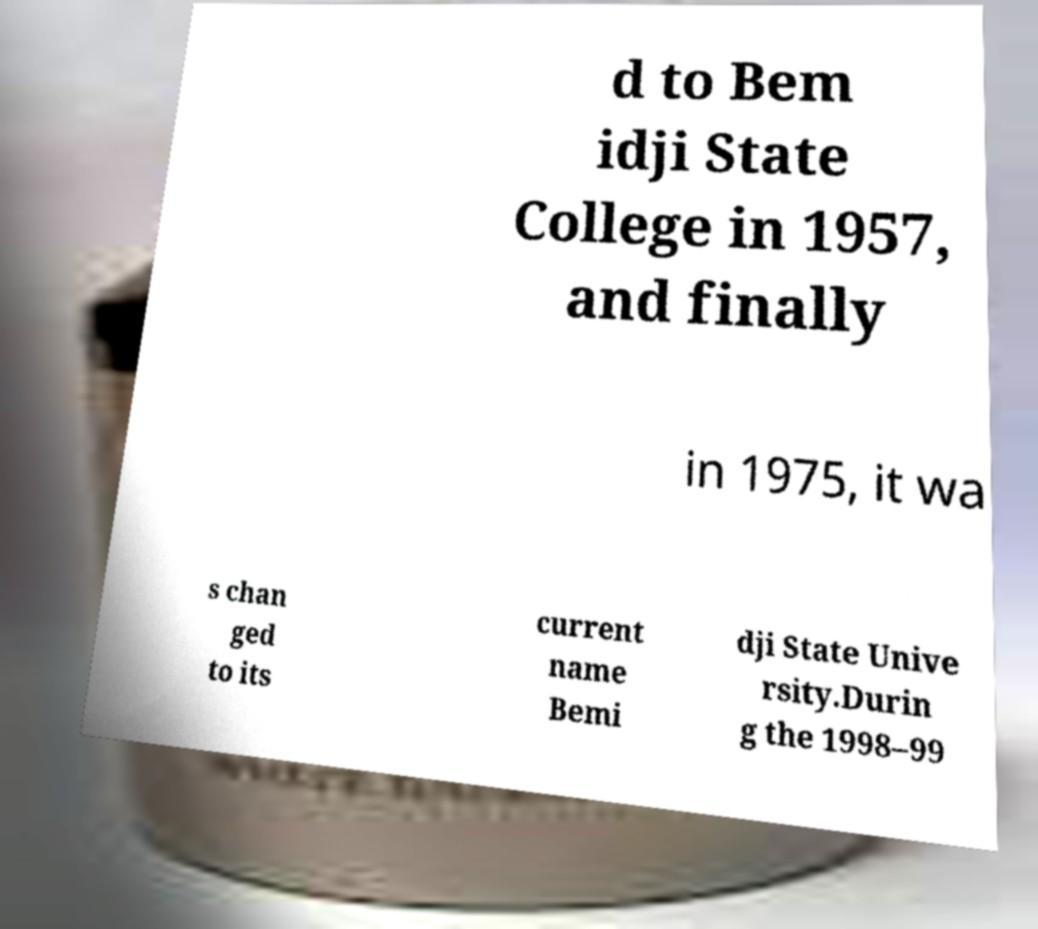For documentation purposes, I need the text within this image transcribed. Could you provide that? d to Bem idji State College in 1957, and finally in 1975, it wa s chan ged to its current name Bemi dji State Unive rsity.Durin g the 1998–99 